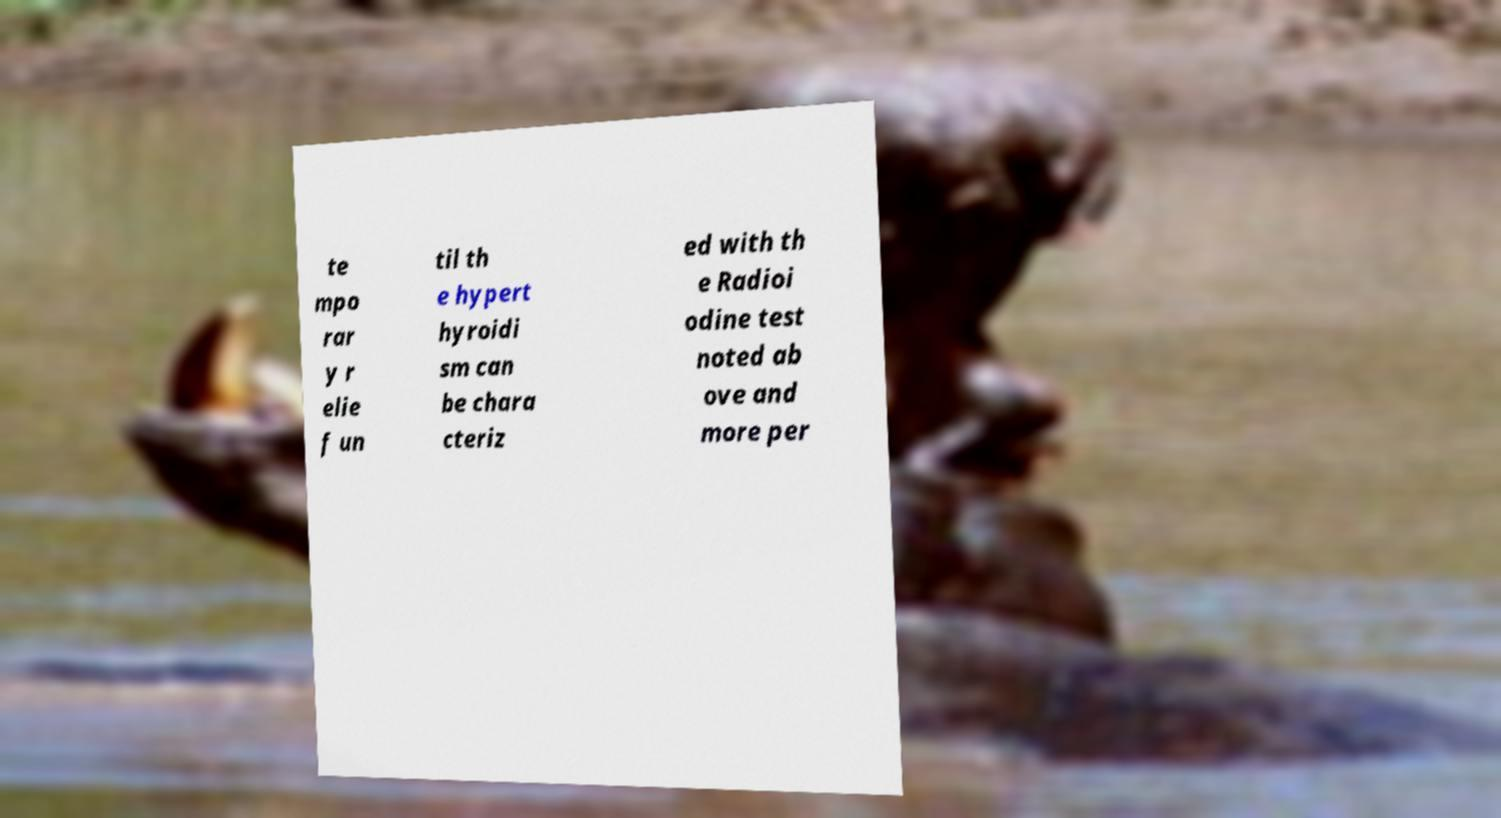There's text embedded in this image that I need extracted. Can you transcribe it verbatim? te mpo rar y r elie f un til th e hypert hyroidi sm can be chara cteriz ed with th e Radioi odine test noted ab ove and more per 